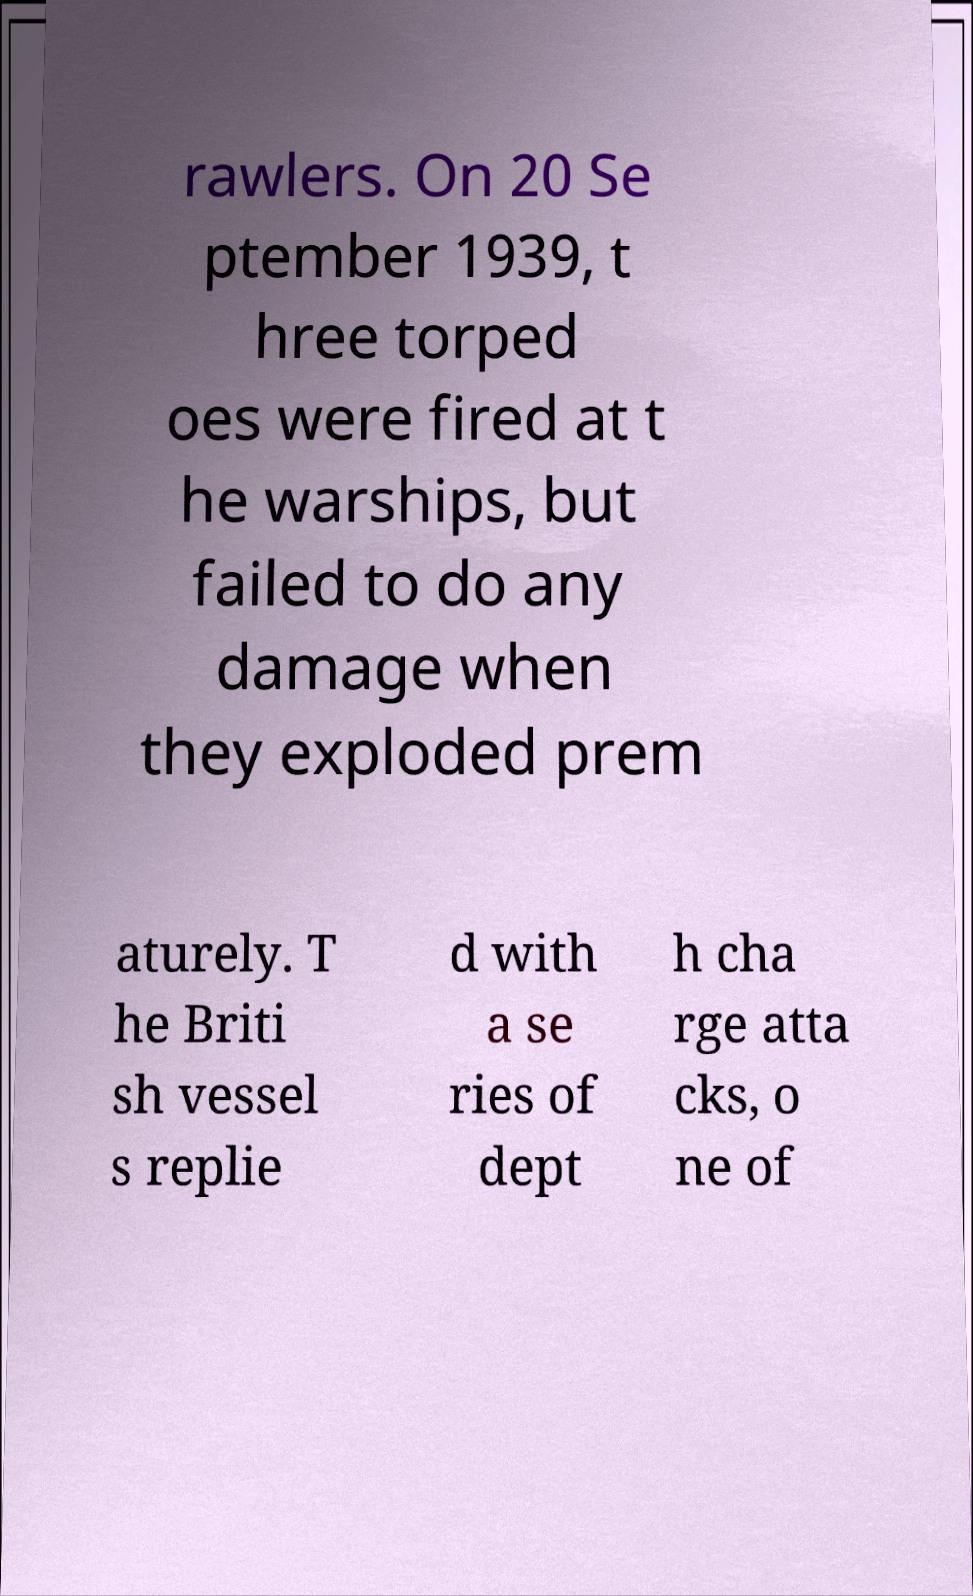For documentation purposes, I need the text within this image transcribed. Could you provide that? rawlers. On 20 Se ptember 1939, t hree torped oes were fired at t he warships, but failed to do any damage when they exploded prem aturely. T he Briti sh vessel s replie d with a se ries of dept h cha rge atta cks, o ne of 